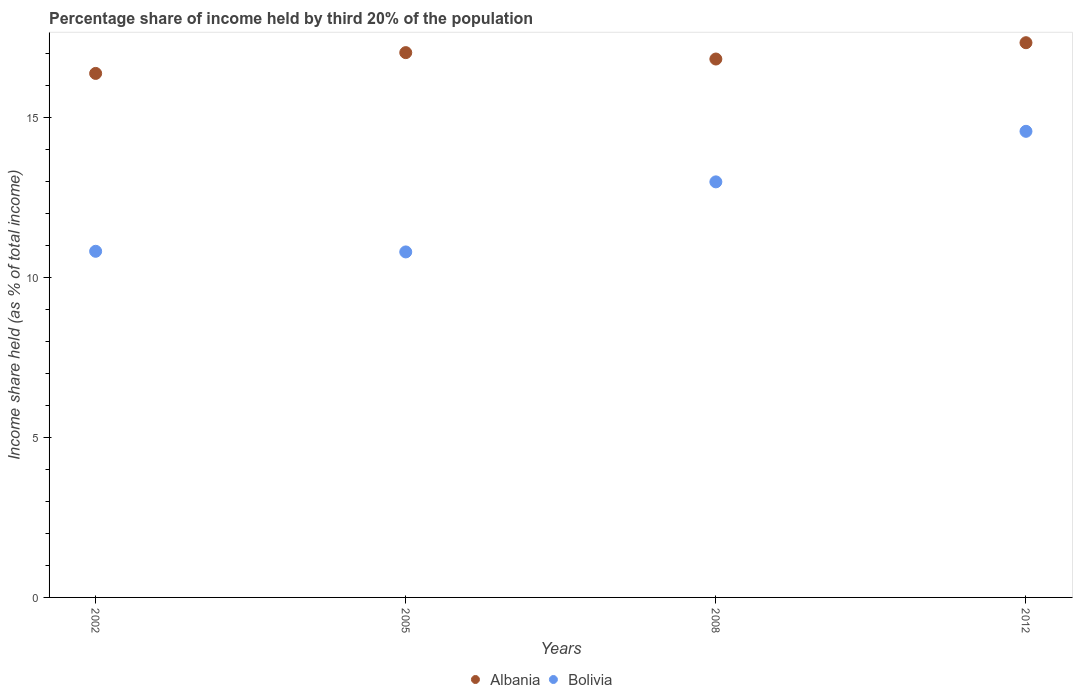How many different coloured dotlines are there?
Give a very brief answer. 2. Is the number of dotlines equal to the number of legend labels?
Keep it short and to the point. Yes. What is the share of income held by third 20% of the population in Albania in 2002?
Offer a very short reply. 16.38. Across all years, what is the maximum share of income held by third 20% of the population in Bolivia?
Make the answer very short. 14.57. Across all years, what is the minimum share of income held by third 20% of the population in Bolivia?
Your answer should be compact. 10.8. In which year was the share of income held by third 20% of the population in Bolivia minimum?
Give a very brief answer. 2005. What is the total share of income held by third 20% of the population in Bolivia in the graph?
Keep it short and to the point. 49.18. What is the difference between the share of income held by third 20% of the population in Bolivia in 2008 and that in 2012?
Provide a succinct answer. -1.58. What is the difference between the share of income held by third 20% of the population in Albania in 2005 and the share of income held by third 20% of the population in Bolivia in 2008?
Provide a succinct answer. 4.04. What is the average share of income held by third 20% of the population in Albania per year?
Offer a terse response. 16.89. In the year 2008, what is the difference between the share of income held by third 20% of the population in Bolivia and share of income held by third 20% of the population in Albania?
Offer a terse response. -3.84. What is the ratio of the share of income held by third 20% of the population in Bolivia in 2002 to that in 2008?
Your answer should be compact. 0.83. Is the share of income held by third 20% of the population in Bolivia in 2008 less than that in 2012?
Your answer should be compact. Yes. What is the difference between the highest and the second highest share of income held by third 20% of the population in Bolivia?
Your answer should be compact. 1.58. What is the difference between the highest and the lowest share of income held by third 20% of the population in Bolivia?
Offer a very short reply. 3.77. Does the share of income held by third 20% of the population in Albania monotonically increase over the years?
Provide a succinct answer. No. Is the share of income held by third 20% of the population in Albania strictly greater than the share of income held by third 20% of the population in Bolivia over the years?
Ensure brevity in your answer.  Yes. Is the share of income held by third 20% of the population in Bolivia strictly less than the share of income held by third 20% of the population in Albania over the years?
Ensure brevity in your answer.  Yes. How many dotlines are there?
Your answer should be compact. 2. How many years are there in the graph?
Offer a very short reply. 4. Does the graph contain grids?
Your answer should be compact. No. How many legend labels are there?
Your answer should be compact. 2. What is the title of the graph?
Keep it short and to the point. Percentage share of income held by third 20% of the population. What is the label or title of the X-axis?
Your answer should be very brief. Years. What is the label or title of the Y-axis?
Your answer should be compact. Income share held (as % of total income). What is the Income share held (as % of total income) of Albania in 2002?
Offer a terse response. 16.38. What is the Income share held (as % of total income) of Bolivia in 2002?
Ensure brevity in your answer.  10.82. What is the Income share held (as % of total income) in Albania in 2005?
Your answer should be very brief. 17.03. What is the Income share held (as % of total income) of Albania in 2008?
Make the answer very short. 16.83. What is the Income share held (as % of total income) in Bolivia in 2008?
Your answer should be very brief. 12.99. What is the Income share held (as % of total income) in Albania in 2012?
Make the answer very short. 17.34. What is the Income share held (as % of total income) in Bolivia in 2012?
Ensure brevity in your answer.  14.57. Across all years, what is the maximum Income share held (as % of total income) in Albania?
Provide a succinct answer. 17.34. Across all years, what is the maximum Income share held (as % of total income) in Bolivia?
Ensure brevity in your answer.  14.57. Across all years, what is the minimum Income share held (as % of total income) in Albania?
Provide a short and direct response. 16.38. What is the total Income share held (as % of total income) in Albania in the graph?
Offer a very short reply. 67.58. What is the total Income share held (as % of total income) in Bolivia in the graph?
Give a very brief answer. 49.18. What is the difference between the Income share held (as % of total income) in Albania in 2002 and that in 2005?
Provide a succinct answer. -0.65. What is the difference between the Income share held (as % of total income) of Albania in 2002 and that in 2008?
Offer a terse response. -0.45. What is the difference between the Income share held (as % of total income) of Bolivia in 2002 and that in 2008?
Your answer should be compact. -2.17. What is the difference between the Income share held (as % of total income) in Albania in 2002 and that in 2012?
Your answer should be very brief. -0.96. What is the difference between the Income share held (as % of total income) of Bolivia in 2002 and that in 2012?
Give a very brief answer. -3.75. What is the difference between the Income share held (as % of total income) of Albania in 2005 and that in 2008?
Your answer should be very brief. 0.2. What is the difference between the Income share held (as % of total income) in Bolivia in 2005 and that in 2008?
Provide a succinct answer. -2.19. What is the difference between the Income share held (as % of total income) of Albania in 2005 and that in 2012?
Your answer should be very brief. -0.31. What is the difference between the Income share held (as % of total income) in Bolivia in 2005 and that in 2012?
Your response must be concise. -3.77. What is the difference between the Income share held (as % of total income) in Albania in 2008 and that in 2012?
Your answer should be compact. -0.51. What is the difference between the Income share held (as % of total income) of Bolivia in 2008 and that in 2012?
Ensure brevity in your answer.  -1.58. What is the difference between the Income share held (as % of total income) in Albania in 2002 and the Income share held (as % of total income) in Bolivia in 2005?
Offer a terse response. 5.58. What is the difference between the Income share held (as % of total income) in Albania in 2002 and the Income share held (as % of total income) in Bolivia in 2008?
Provide a short and direct response. 3.39. What is the difference between the Income share held (as % of total income) of Albania in 2002 and the Income share held (as % of total income) of Bolivia in 2012?
Offer a terse response. 1.81. What is the difference between the Income share held (as % of total income) in Albania in 2005 and the Income share held (as % of total income) in Bolivia in 2008?
Ensure brevity in your answer.  4.04. What is the difference between the Income share held (as % of total income) in Albania in 2005 and the Income share held (as % of total income) in Bolivia in 2012?
Offer a very short reply. 2.46. What is the difference between the Income share held (as % of total income) of Albania in 2008 and the Income share held (as % of total income) of Bolivia in 2012?
Your answer should be compact. 2.26. What is the average Income share held (as % of total income) of Albania per year?
Keep it short and to the point. 16.89. What is the average Income share held (as % of total income) in Bolivia per year?
Offer a terse response. 12.29. In the year 2002, what is the difference between the Income share held (as % of total income) in Albania and Income share held (as % of total income) in Bolivia?
Make the answer very short. 5.56. In the year 2005, what is the difference between the Income share held (as % of total income) in Albania and Income share held (as % of total income) in Bolivia?
Make the answer very short. 6.23. In the year 2008, what is the difference between the Income share held (as % of total income) of Albania and Income share held (as % of total income) of Bolivia?
Provide a short and direct response. 3.84. In the year 2012, what is the difference between the Income share held (as % of total income) of Albania and Income share held (as % of total income) of Bolivia?
Make the answer very short. 2.77. What is the ratio of the Income share held (as % of total income) in Albania in 2002 to that in 2005?
Your answer should be very brief. 0.96. What is the ratio of the Income share held (as % of total income) in Albania in 2002 to that in 2008?
Ensure brevity in your answer.  0.97. What is the ratio of the Income share held (as % of total income) of Bolivia in 2002 to that in 2008?
Offer a terse response. 0.83. What is the ratio of the Income share held (as % of total income) of Albania in 2002 to that in 2012?
Keep it short and to the point. 0.94. What is the ratio of the Income share held (as % of total income) of Bolivia in 2002 to that in 2012?
Give a very brief answer. 0.74. What is the ratio of the Income share held (as % of total income) of Albania in 2005 to that in 2008?
Your answer should be very brief. 1.01. What is the ratio of the Income share held (as % of total income) in Bolivia in 2005 to that in 2008?
Provide a short and direct response. 0.83. What is the ratio of the Income share held (as % of total income) in Albania in 2005 to that in 2012?
Provide a succinct answer. 0.98. What is the ratio of the Income share held (as % of total income) of Bolivia in 2005 to that in 2012?
Your response must be concise. 0.74. What is the ratio of the Income share held (as % of total income) of Albania in 2008 to that in 2012?
Ensure brevity in your answer.  0.97. What is the ratio of the Income share held (as % of total income) in Bolivia in 2008 to that in 2012?
Offer a very short reply. 0.89. What is the difference between the highest and the second highest Income share held (as % of total income) of Albania?
Your response must be concise. 0.31. What is the difference between the highest and the second highest Income share held (as % of total income) of Bolivia?
Your response must be concise. 1.58. What is the difference between the highest and the lowest Income share held (as % of total income) of Albania?
Keep it short and to the point. 0.96. What is the difference between the highest and the lowest Income share held (as % of total income) in Bolivia?
Your answer should be compact. 3.77. 